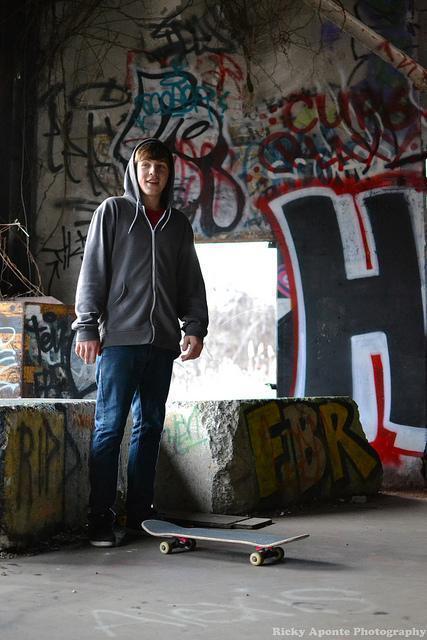How many skateboards are in the picture?
Give a very brief answer. 1. 